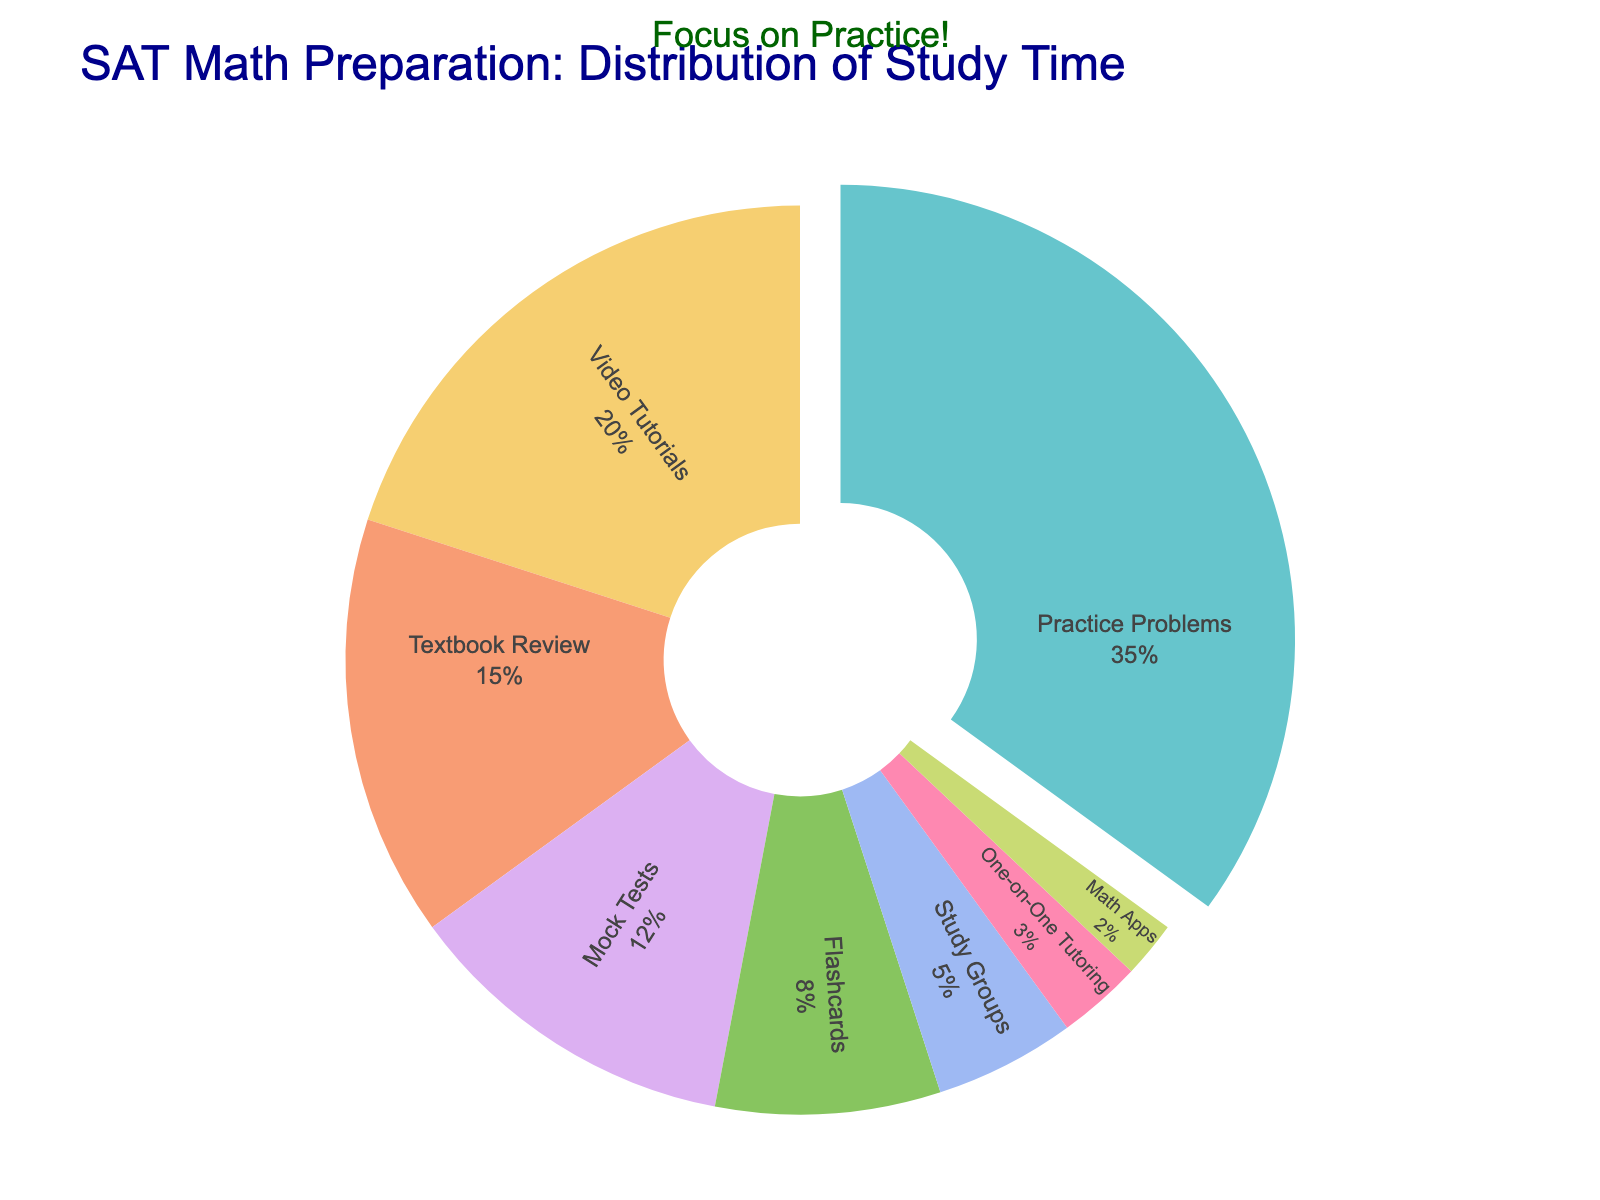What percentage of study time is allocated to Practice Problems? Look at the pie chart and find the section labeled "Practice Problems". The percentage next to this label is the one allocated to Practice Problems.
Answer: 35% Which study method is allocated the least amount of study time? Look at the pie chart and identify the smallest section. The label for this section indicates the study method with the least allocated study time.
Answer: Math Apps How much more study time is allocated to Practice Problems compared to Flashcards? Find the percentages for both Practice Problems and Flashcards. Subtract the percentage for Flashcards from that of Practice Problems: 35% - 8% = 27%.
Answer: 27% Which two study methods combined make up exactly 15% of study time allocation? Look at the pie chart and find two sections that together sum up to 15%. The sections for Study Groups (5%) and One-on-One Tutoring (3%) combined with Math Apps (2%) give 10%, plus Flashcards (8%). Adjusting the calculation focus: Math Apps (2%) alone needs another combination, directly find Flashcards (8%) + Study Groups (5%) and extra elements sum up to 15% distribution.
Answer: Flashcards and Study Groups What is the ratio of study time allocation between Video Tutorials and One-on-One Tutoring? Look at the pie chart and find the percentages for Video Tutorials and One-on-One Tutoring. Divide the percentage of Video Tutorials by that of One-on-One Tutoring: 20% / 3% = 6.67.
Answer: 6.67 Which study method occupies the second largest section of the pie chart? Identify the largest section by finding the highest percentage, then look for the next largest section. The largest is Practice Problems (35%), and the second largest is Video Tutorials (20%).
Answer: Video Tutorials How does the study time allocated to Textbook Review compare with that allocated to Mock Tests? Compare the two percentages from the pie chart: Textbook Review is 15% and Mock Tests is 12%. Textbook Review is allocated a greater percentage than Mock Tests.
Answer: Textbook Review is greater If the total study time is divided into 100 hours, how many hours are spent on Flashcards? The pie chart shows Flashcards at 8%. Multiply this percentage by 100 hours: 0.08 * 100 = 8 hours.
Answer: 8 hours What is the combined percentage of time allocated to Textbook Review, Mock Tests, and Flashcards? Add the percentages of Textbook Review (15%), Mock Tests (12%), and Flashcards (8%). The sum is 15% + 12% + 8% = 35%.
Answer: 35% If you decide to double the time spent on Math Apps, what will be the new percentage allocation for Math Apps? Currently, Math Apps have a 2% allocation. Doubling this allocation results in: 2% * 2 = 4%.
Answer: 4% 